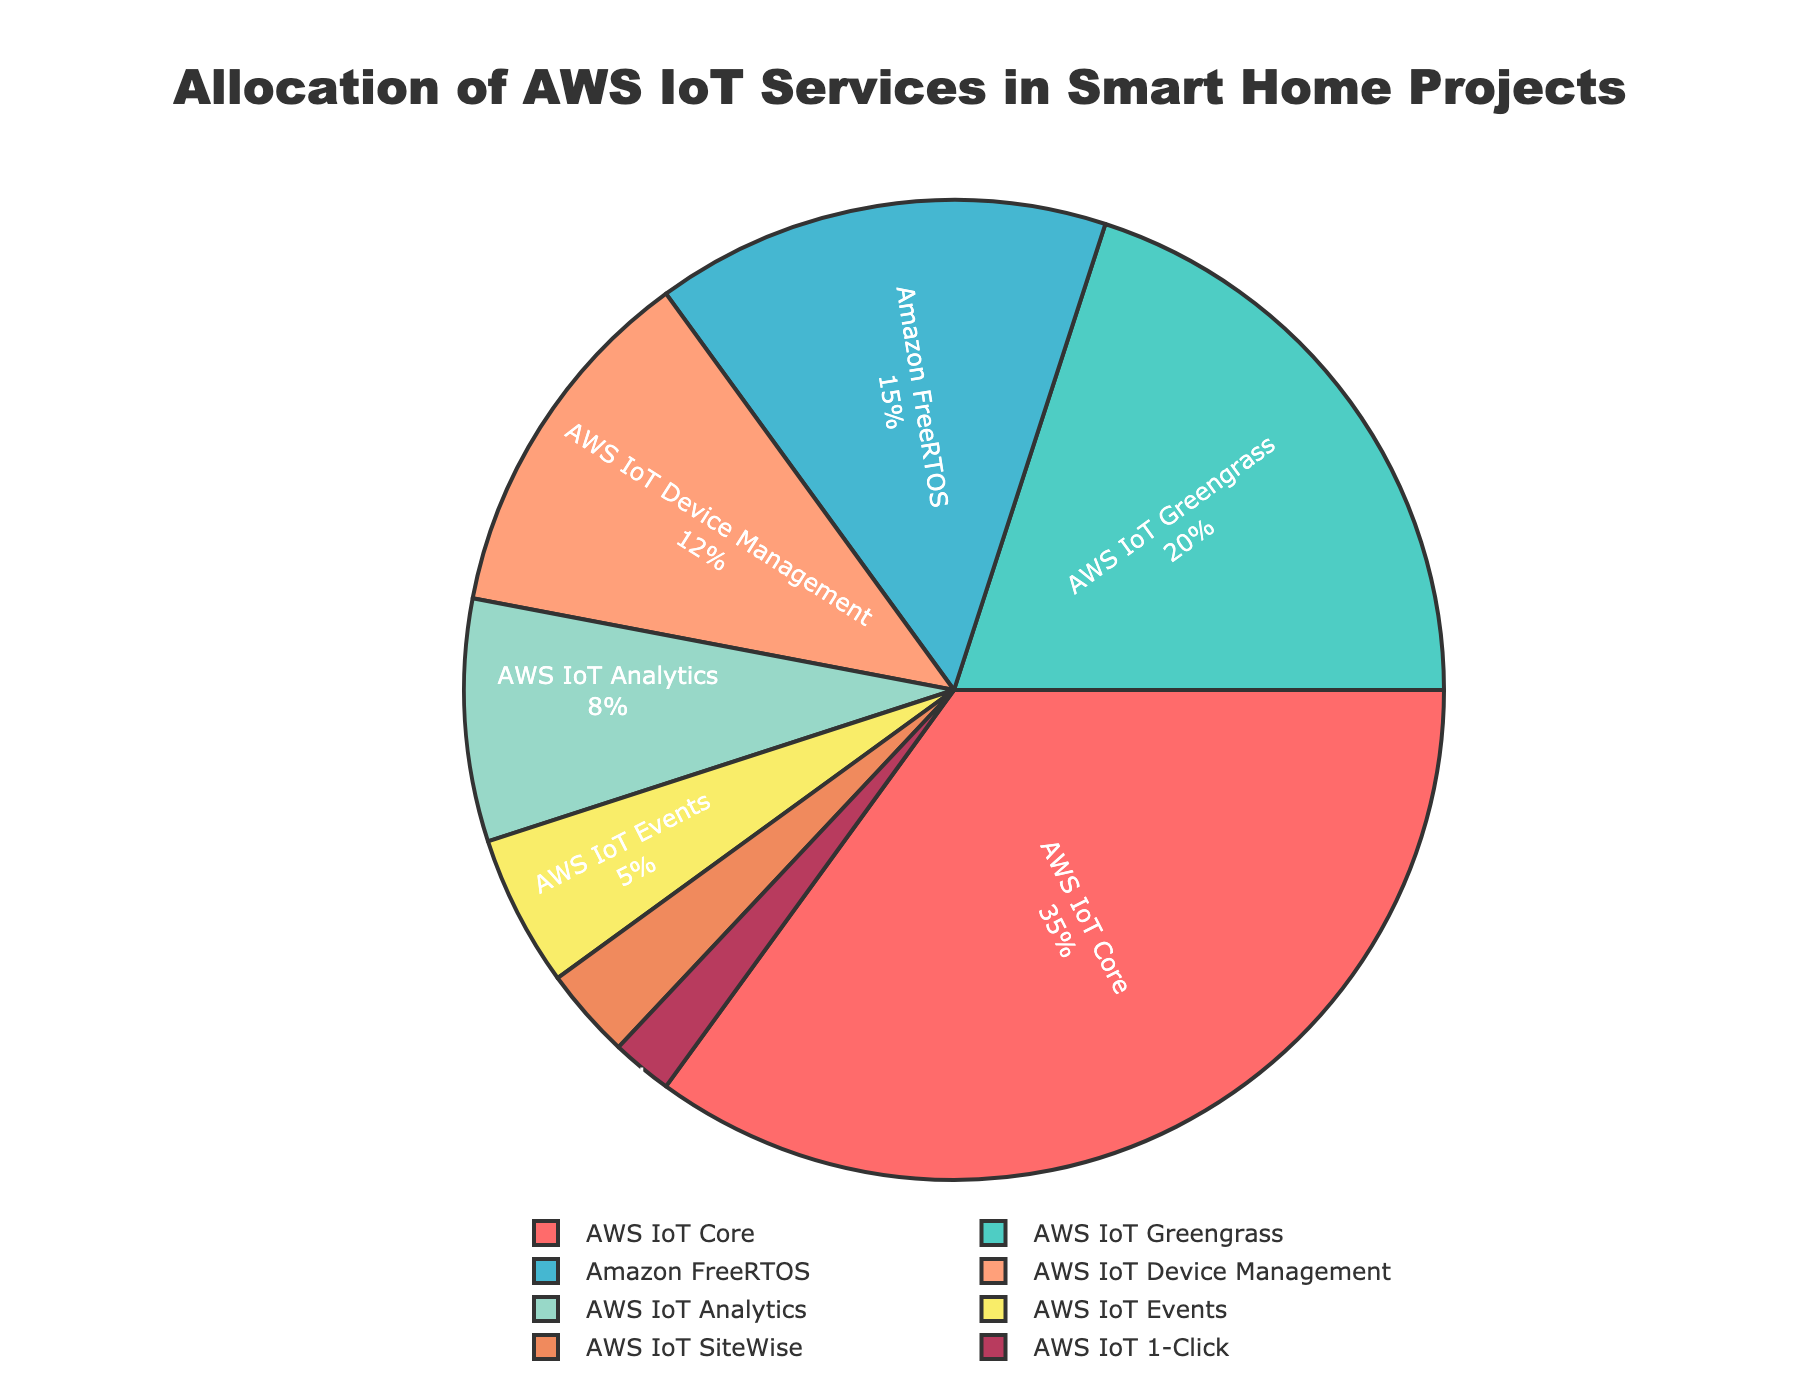Which AWS IoT service has the highest allocation in smart home projects? The pie chart shows multiple segments with different percentages. The segment labeled "AWS IoT Core" has the highest percentage at 35%.
Answer: AWS IoT Core By how many percentage points is AWS IoT Core usage greater than AWS IoT Greengrass? AWS IoT Core is at 35% while AWS IoT Greengrass is at 20%. The difference is 35% - 20% = 15%.
Answer: 15% If you combine the allocation percentages of AWS IoT Analytics and AWS IoT Events, what is the total percentage? AWS IoT Analytics has 8% and AWS IoT Events has 5%. Summing these gives 8% + 5% = 13%.
Answer: 13% Which AWS IoT service has the smallest allocation and what is its percentage? The pie chart has a segment labeled "AWS IoT 1-Click" with the smallest percentage at 2%.
Answer: AWS IoT 1-Click, 2% Which service occupies the light blue segment, and what percentage does it represent? The pie chart shows the light blue segment is labeled as "AWS IoT Greengrass." It represents 20%.
Answer: AWS IoT Greengrass, 20% What is the combined percentage of allocations for AWS IoT Core and Amazon FreeRTOS? AWS IoT Core is allocated 35% and Amazon FreeRTOS is allocated 15%. The combined total is 35% + 15% = 50%.
Answer: 50% What percentage of the chart is represented by AWS IoT Device Management and AWS IoT Analytics together? AWS IoT Device Management is at 12% and AWS IoT Analytics is at 8%. Adding these together gives 12% + 8% = 20%.
Answer: 20% Which two services together make up exactly one-third of the pie chart? One-third of the pie chart is 33.33%. AWS IoT Greengrass is 20% and Amazon FreeRTOS is 15%. Together they make 20% + 15% = 35%, which is close to one-third. However, AWS IoT Greengrass and AWS IoT Device Management together add up to 20% + 12% = 32%, which is closer to one-third.
Answer: AWS IoT Greengrass and AWS IoT Device Management How does the allocation for AWS IoT SiteWise compare to that of AWS IoT 1-Click? AWS IoT SiteWise has a 3% allocation, and AWS IoT 1-Click has a 2% allocation. Comparing them, AWS IoT SiteWise has 1% more allocation than AWS IoT 1-Click.
Answer: AWS IoT SiteWise has 1% more than AWS IoT 1-Click 